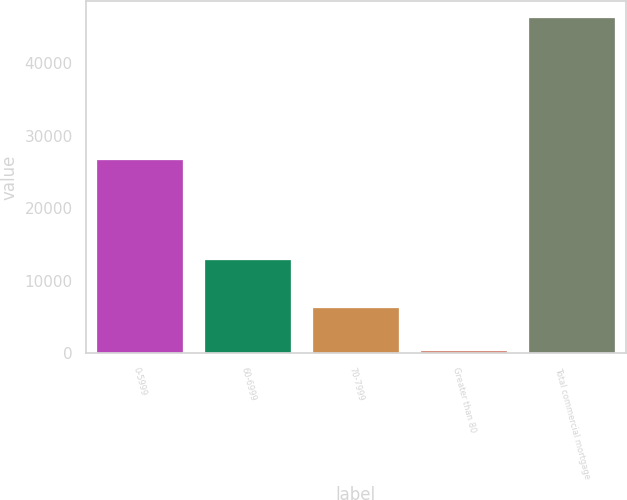Convert chart to OTSL. <chart><loc_0><loc_0><loc_500><loc_500><bar_chart><fcel>0-5999<fcel>60-6999<fcel>70-7999<fcel>Greater than 80<fcel>Total commercial mortgage<nl><fcel>26700<fcel>12820<fcel>6265<fcel>402<fcel>46187<nl></chart> 